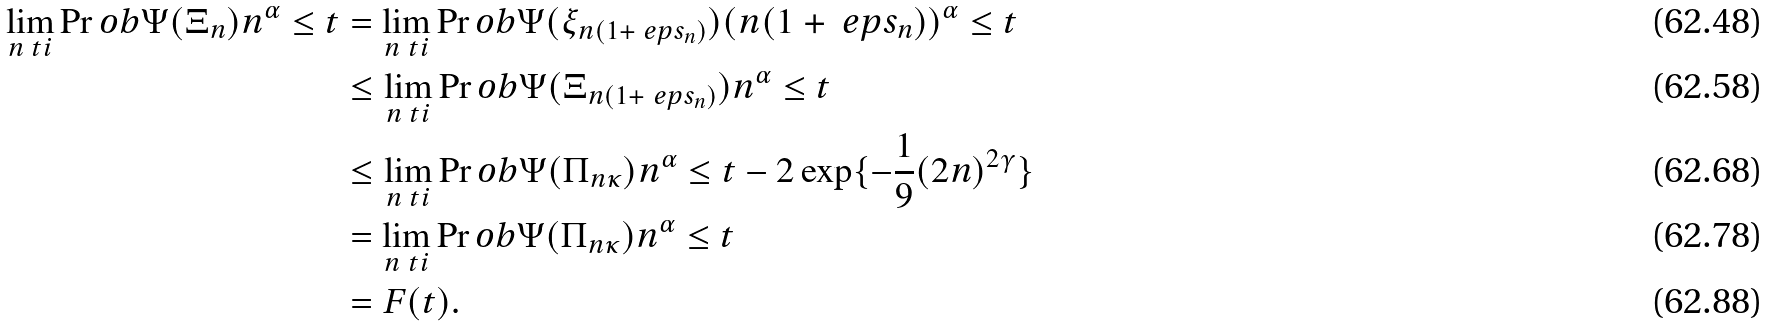Convert formula to latex. <formula><loc_0><loc_0><loc_500><loc_500>\lim _ { n \ t i } \Pr o b { \Psi ( \Xi _ { n } ) n ^ { \alpha } \leq t } & = \lim _ { n \ t i } \Pr o b { \Psi ( \xi _ { n ( 1 + \ e p s _ { n } ) } ) ( n ( 1 + \ e p s _ { n } ) ) ^ { \alpha } \leq t } \\ & \leq \lim _ { n \ t i } \Pr o b { \Psi ( \Xi _ { n ( 1 + \ e p s _ { n } ) } ) n ^ { \alpha } \leq t } \\ & \leq \lim _ { n \ t i } \Pr o b { \Psi ( \Pi _ { n \kappa } ) n ^ { \alpha } \leq t } - 2 \exp \{ - \frac { 1 } { 9 } ( 2 n ) ^ { 2 \gamma } \} \\ & = \lim _ { n \ t i } \Pr o b { \Psi ( \Pi _ { n \kappa } ) n ^ { \alpha } \leq t } \\ & = F ( t ) .</formula> 